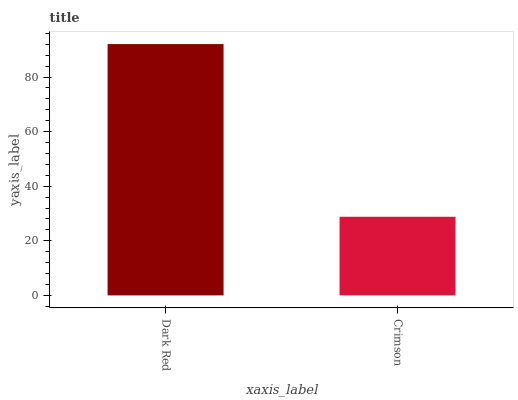Is Crimson the maximum?
Answer yes or no. No. Is Dark Red greater than Crimson?
Answer yes or no. Yes. Is Crimson less than Dark Red?
Answer yes or no. Yes. Is Crimson greater than Dark Red?
Answer yes or no. No. Is Dark Red less than Crimson?
Answer yes or no. No. Is Dark Red the high median?
Answer yes or no. Yes. Is Crimson the low median?
Answer yes or no. Yes. Is Crimson the high median?
Answer yes or no. No. Is Dark Red the low median?
Answer yes or no. No. 